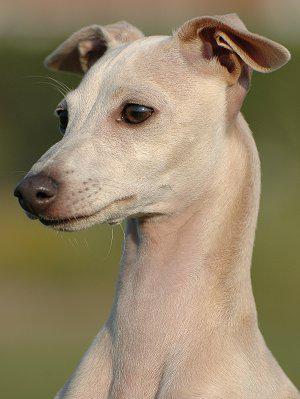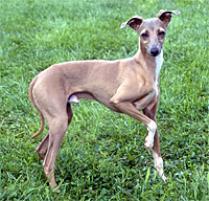The first image is the image on the left, the second image is the image on the right. Considering the images on both sides, is "The right image shows a hound standing on thick green grass." valid? Answer yes or no. Yes. 